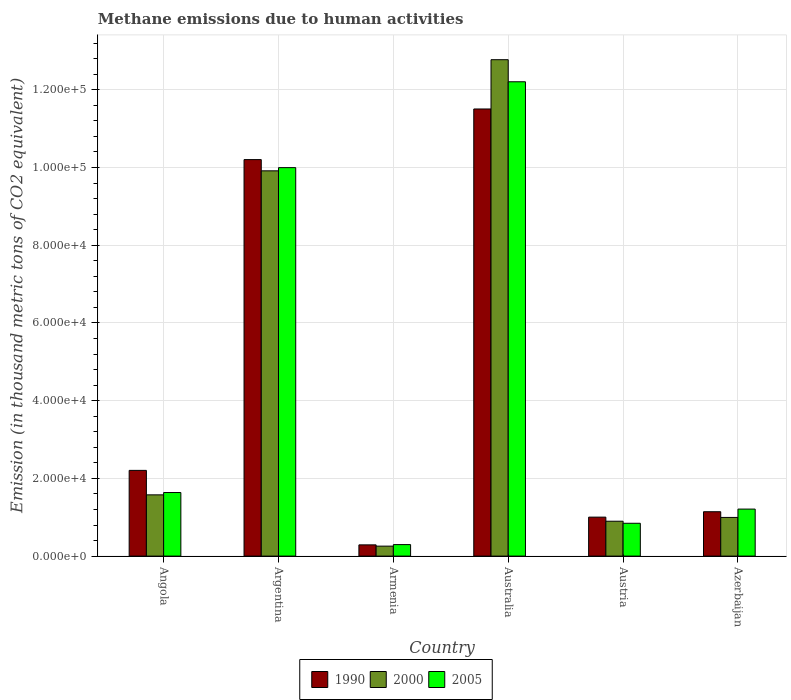How many bars are there on the 6th tick from the left?
Offer a very short reply. 3. What is the amount of methane emitted in 2005 in Austria?
Offer a very short reply. 8447.3. Across all countries, what is the maximum amount of methane emitted in 2005?
Keep it short and to the point. 1.22e+05. Across all countries, what is the minimum amount of methane emitted in 1990?
Offer a terse response. 2890.7. In which country was the amount of methane emitted in 2000 maximum?
Provide a short and direct response. Australia. In which country was the amount of methane emitted in 1990 minimum?
Ensure brevity in your answer.  Armenia. What is the total amount of methane emitted in 2000 in the graph?
Ensure brevity in your answer.  2.64e+05. What is the difference between the amount of methane emitted in 1990 in Angola and that in Azerbaijan?
Offer a very short reply. 1.06e+04. What is the difference between the amount of methane emitted in 2005 in Armenia and the amount of methane emitted in 2000 in Azerbaijan?
Provide a short and direct response. -6990.6. What is the average amount of methane emitted in 2005 per country?
Provide a succinct answer. 4.36e+04. What is the difference between the amount of methane emitted of/in 2000 and amount of methane emitted of/in 2005 in Austria?
Offer a terse response. 525.1. In how many countries, is the amount of methane emitted in 2000 greater than 24000 thousand metric tons?
Your answer should be very brief. 2. What is the ratio of the amount of methane emitted in 2000 in Angola to that in Australia?
Ensure brevity in your answer.  0.12. Is the amount of methane emitted in 1990 in Argentina less than that in Azerbaijan?
Offer a terse response. No. What is the difference between the highest and the second highest amount of methane emitted in 2005?
Make the answer very short. 8.36e+04. What is the difference between the highest and the lowest amount of methane emitted in 2005?
Your answer should be compact. 1.19e+05. Is it the case that in every country, the sum of the amount of methane emitted in 2005 and amount of methane emitted in 1990 is greater than the amount of methane emitted in 2000?
Provide a short and direct response. Yes. How many countries are there in the graph?
Give a very brief answer. 6. What is the difference between two consecutive major ticks on the Y-axis?
Ensure brevity in your answer.  2.00e+04. Are the values on the major ticks of Y-axis written in scientific E-notation?
Your response must be concise. Yes. Does the graph contain any zero values?
Your answer should be very brief. No. Does the graph contain grids?
Provide a succinct answer. Yes. How many legend labels are there?
Offer a terse response. 3. What is the title of the graph?
Offer a very short reply. Methane emissions due to human activities. What is the label or title of the X-axis?
Give a very brief answer. Country. What is the label or title of the Y-axis?
Give a very brief answer. Emission (in thousand metric tons of CO2 equivalent). What is the Emission (in thousand metric tons of CO2 equivalent) in 1990 in Angola?
Offer a terse response. 2.21e+04. What is the Emission (in thousand metric tons of CO2 equivalent) in 2000 in Angola?
Your response must be concise. 1.58e+04. What is the Emission (in thousand metric tons of CO2 equivalent) of 2005 in Angola?
Ensure brevity in your answer.  1.64e+04. What is the Emission (in thousand metric tons of CO2 equivalent) of 1990 in Argentina?
Keep it short and to the point. 1.02e+05. What is the Emission (in thousand metric tons of CO2 equivalent) of 2000 in Argentina?
Provide a succinct answer. 9.91e+04. What is the Emission (in thousand metric tons of CO2 equivalent) of 2005 in Argentina?
Your answer should be very brief. 1.00e+05. What is the Emission (in thousand metric tons of CO2 equivalent) of 1990 in Armenia?
Ensure brevity in your answer.  2890.7. What is the Emission (in thousand metric tons of CO2 equivalent) of 2000 in Armenia?
Give a very brief answer. 2565.3. What is the Emission (in thousand metric tons of CO2 equivalent) of 2005 in Armenia?
Your answer should be compact. 2960.3. What is the Emission (in thousand metric tons of CO2 equivalent) of 1990 in Australia?
Provide a short and direct response. 1.15e+05. What is the Emission (in thousand metric tons of CO2 equivalent) in 2000 in Australia?
Offer a very short reply. 1.28e+05. What is the Emission (in thousand metric tons of CO2 equivalent) of 2005 in Australia?
Offer a terse response. 1.22e+05. What is the Emission (in thousand metric tons of CO2 equivalent) of 1990 in Austria?
Offer a very short reply. 1.00e+04. What is the Emission (in thousand metric tons of CO2 equivalent) of 2000 in Austria?
Your response must be concise. 8972.4. What is the Emission (in thousand metric tons of CO2 equivalent) in 2005 in Austria?
Keep it short and to the point. 8447.3. What is the Emission (in thousand metric tons of CO2 equivalent) of 1990 in Azerbaijan?
Your response must be concise. 1.14e+04. What is the Emission (in thousand metric tons of CO2 equivalent) of 2000 in Azerbaijan?
Provide a succinct answer. 9950.9. What is the Emission (in thousand metric tons of CO2 equivalent) in 2005 in Azerbaijan?
Offer a very short reply. 1.21e+04. Across all countries, what is the maximum Emission (in thousand metric tons of CO2 equivalent) of 1990?
Ensure brevity in your answer.  1.15e+05. Across all countries, what is the maximum Emission (in thousand metric tons of CO2 equivalent) in 2000?
Make the answer very short. 1.28e+05. Across all countries, what is the maximum Emission (in thousand metric tons of CO2 equivalent) in 2005?
Ensure brevity in your answer.  1.22e+05. Across all countries, what is the minimum Emission (in thousand metric tons of CO2 equivalent) of 1990?
Give a very brief answer. 2890.7. Across all countries, what is the minimum Emission (in thousand metric tons of CO2 equivalent) of 2000?
Offer a very short reply. 2565.3. Across all countries, what is the minimum Emission (in thousand metric tons of CO2 equivalent) in 2005?
Your answer should be very brief. 2960.3. What is the total Emission (in thousand metric tons of CO2 equivalent) of 1990 in the graph?
Make the answer very short. 2.63e+05. What is the total Emission (in thousand metric tons of CO2 equivalent) in 2000 in the graph?
Make the answer very short. 2.64e+05. What is the total Emission (in thousand metric tons of CO2 equivalent) of 2005 in the graph?
Give a very brief answer. 2.62e+05. What is the difference between the Emission (in thousand metric tons of CO2 equivalent) of 1990 in Angola and that in Argentina?
Provide a short and direct response. -8.00e+04. What is the difference between the Emission (in thousand metric tons of CO2 equivalent) of 2000 in Angola and that in Argentina?
Give a very brief answer. -8.34e+04. What is the difference between the Emission (in thousand metric tons of CO2 equivalent) of 2005 in Angola and that in Argentina?
Ensure brevity in your answer.  -8.36e+04. What is the difference between the Emission (in thousand metric tons of CO2 equivalent) in 1990 in Angola and that in Armenia?
Your response must be concise. 1.92e+04. What is the difference between the Emission (in thousand metric tons of CO2 equivalent) in 2000 in Angola and that in Armenia?
Make the answer very short. 1.32e+04. What is the difference between the Emission (in thousand metric tons of CO2 equivalent) in 2005 in Angola and that in Armenia?
Ensure brevity in your answer.  1.34e+04. What is the difference between the Emission (in thousand metric tons of CO2 equivalent) in 1990 in Angola and that in Australia?
Your answer should be very brief. -9.30e+04. What is the difference between the Emission (in thousand metric tons of CO2 equivalent) of 2000 in Angola and that in Australia?
Provide a short and direct response. -1.12e+05. What is the difference between the Emission (in thousand metric tons of CO2 equivalent) of 2005 in Angola and that in Australia?
Provide a succinct answer. -1.06e+05. What is the difference between the Emission (in thousand metric tons of CO2 equivalent) of 1990 in Angola and that in Austria?
Make the answer very short. 1.20e+04. What is the difference between the Emission (in thousand metric tons of CO2 equivalent) of 2000 in Angola and that in Austria?
Give a very brief answer. 6786.2. What is the difference between the Emission (in thousand metric tons of CO2 equivalent) in 2005 in Angola and that in Austria?
Ensure brevity in your answer.  7911.4. What is the difference between the Emission (in thousand metric tons of CO2 equivalent) of 1990 in Angola and that in Azerbaijan?
Offer a very short reply. 1.06e+04. What is the difference between the Emission (in thousand metric tons of CO2 equivalent) in 2000 in Angola and that in Azerbaijan?
Ensure brevity in your answer.  5807.7. What is the difference between the Emission (in thousand metric tons of CO2 equivalent) of 2005 in Angola and that in Azerbaijan?
Offer a very short reply. 4262.4. What is the difference between the Emission (in thousand metric tons of CO2 equivalent) in 1990 in Argentina and that in Armenia?
Offer a very short reply. 9.91e+04. What is the difference between the Emission (in thousand metric tons of CO2 equivalent) of 2000 in Argentina and that in Armenia?
Your response must be concise. 9.66e+04. What is the difference between the Emission (in thousand metric tons of CO2 equivalent) in 2005 in Argentina and that in Armenia?
Provide a short and direct response. 9.70e+04. What is the difference between the Emission (in thousand metric tons of CO2 equivalent) of 1990 in Argentina and that in Australia?
Your response must be concise. -1.30e+04. What is the difference between the Emission (in thousand metric tons of CO2 equivalent) of 2000 in Argentina and that in Australia?
Your answer should be very brief. -2.86e+04. What is the difference between the Emission (in thousand metric tons of CO2 equivalent) of 2005 in Argentina and that in Australia?
Keep it short and to the point. -2.21e+04. What is the difference between the Emission (in thousand metric tons of CO2 equivalent) in 1990 in Argentina and that in Austria?
Your answer should be very brief. 9.20e+04. What is the difference between the Emission (in thousand metric tons of CO2 equivalent) in 2000 in Argentina and that in Austria?
Give a very brief answer. 9.02e+04. What is the difference between the Emission (in thousand metric tons of CO2 equivalent) in 2005 in Argentina and that in Austria?
Your response must be concise. 9.15e+04. What is the difference between the Emission (in thousand metric tons of CO2 equivalent) in 1990 in Argentina and that in Azerbaijan?
Your answer should be compact. 9.06e+04. What is the difference between the Emission (in thousand metric tons of CO2 equivalent) in 2000 in Argentina and that in Azerbaijan?
Keep it short and to the point. 8.92e+04. What is the difference between the Emission (in thousand metric tons of CO2 equivalent) in 2005 in Argentina and that in Azerbaijan?
Provide a succinct answer. 8.79e+04. What is the difference between the Emission (in thousand metric tons of CO2 equivalent) of 1990 in Armenia and that in Australia?
Your answer should be very brief. -1.12e+05. What is the difference between the Emission (in thousand metric tons of CO2 equivalent) in 2000 in Armenia and that in Australia?
Keep it short and to the point. -1.25e+05. What is the difference between the Emission (in thousand metric tons of CO2 equivalent) in 2005 in Armenia and that in Australia?
Offer a very short reply. -1.19e+05. What is the difference between the Emission (in thousand metric tons of CO2 equivalent) in 1990 in Armenia and that in Austria?
Your answer should be very brief. -7135.8. What is the difference between the Emission (in thousand metric tons of CO2 equivalent) in 2000 in Armenia and that in Austria?
Offer a very short reply. -6407.1. What is the difference between the Emission (in thousand metric tons of CO2 equivalent) of 2005 in Armenia and that in Austria?
Your answer should be very brief. -5487. What is the difference between the Emission (in thousand metric tons of CO2 equivalent) of 1990 in Armenia and that in Azerbaijan?
Your answer should be compact. -8527.5. What is the difference between the Emission (in thousand metric tons of CO2 equivalent) of 2000 in Armenia and that in Azerbaijan?
Your answer should be compact. -7385.6. What is the difference between the Emission (in thousand metric tons of CO2 equivalent) of 2005 in Armenia and that in Azerbaijan?
Provide a succinct answer. -9136. What is the difference between the Emission (in thousand metric tons of CO2 equivalent) of 1990 in Australia and that in Austria?
Provide a short and direct response. 1.05e+05. What is the difference between the Emission (in thousand metric tons of CO2 equivalent) of 2000 in Australia and that in Austria?
Ensure brevity in your answer.  1.19e+05. What is the difference between the Emission (in thousand metric tons of CO2 equivalent) of 2005 in Australia and that in Austria?
Provide a short and direct response. 1.14e+05. What is the difference between the Emission (in thousand metric tons of CO2 equivalent) in 1990 in Australia and that in Azerbaijan?
Keep it short and to the point. 1.04e+05. What is the difference between the Emission (in thousand metric tons of CO2 equivalent) of 2000 in Australia and that in Azerbaijan?
Provide a succinct answer. 1.18e+05. What is the difference between the Emission (in thousand metric tons of CO2 equivalent) of 2005 in Australia and that in Azerbaijan?
Ensure brevity in your answer.  1.10e+05. What is the difference between the Emission (in thousand metric tons of CO2 equivalent) of 1990 in Austria and that in Azerbaijan?
Your response must be concise. -1391.7. What is the difference between the Emission (in thousand metric tons of CO2 equivalent) in 2000 in Austria and that in Azerbaijan?
Your answer should be very brief. -978.5. What is the difference between the Emission (in thousand metric tons of CO2 equivalent) in 2005 in Austria and that in Azerbaijan?
Your response must be concise. -3649. What is the difference between the Emission (in thousand metric tons of CO2 equivalent) in 1990 in Angola and the Emission (in thousand metric tons of CO2 equivalent) in 2000 in Argentina?
Offer a very short reply. -7.71e+04. What is the difference between the Emission (in thousand metric tons of CO2 equivalent) of 1990 in Angola and the Emission (in thousand metric tons of CO2 equivalent) of 2005 in Argentina?
Offer a terse response. -7.79e+04. What is the difference between the Emission (in thousand metric tons of CO2 equivalent) in 2000 in Angola and the Emission (in thousand metric tons of CO2 equivalent) in 2005 in Argentina?
Offer a very short reply. -8.42e+04. What is the difference between the Emission (in thousand metric tons of CO2 equivalent) of 1990 in Angola and the Emission (in thousand metric tons of CO2 equivalent) of 2000 in Armenia?
Keep it short and to the point. 1.95e+04. What is the difference between the Emission (in thousand metric tons of CO2 equivalent) in 1990 in Angola and the Emission (in thousand metric tons of CO2 equivalent) in 2005 in Armenia?
Your answer should be compact. 1.91e+04. What is the difference between the Emission (in thousand metric tons of CO2 equivalent) of 2000 in Angola and the Emission (in thousand metric tons of CO2 equivalent) of 2005 in Armenia?
Ensure brevity in your answer.  1.28e+04. What is the difference between the Emission (in thousand metric tons of CO2 equivalent) of 1990 in Angola and the Emission (in thousand metric tons of CO2 equivalent) of 2000 in Australia?
Your response must be concise. -1.06e+05. What is the difference between the Emission (in thousand metric tons of CO2 equivalent) of 1990 in Angola and the Emission (in thousand metric tons of CO2 equivalent) of 2005 in Australia?
Your answer should be very brief. -1.00e+05. What is the difference between the Emission (in thousand metric tons of CO2 equivalent) of 2000 in Angola and the Emission (in thousand metric tons of CO2 equivalent) of 2005 in Australia?
Your answer should be compact. -1.06e+05. What is the difference between the Emission (in thousand metric tons of CO2 equivalent) in 1990 in Angola and the Emission (in thousand metric tons of CO2 equivalent) in 2000 in Austria?
Your answer should be compact. 1.31e+04. What is the difference between the Emission (in thousand metric tons of CO2 equivalent) in 1990 in Angola and the Emission (in thousand metric tons of CO2 equivalent) in 2005 in Austria?
Give a very brief answer. 1.36e+04. What is the difference between the Emission (in thousand metric tons of CO2 equivalent) of 2000 in Angola and the Emission (in thousand metric tons of CO2 equivalent) of 2005 in Austria?
Give a very brief answer. 7311.3. What is the difference between the Emission (in thousand metric tons of CO2 equivalent) in 1990 in Angola and the Emission (in thousand metric tons of CO2 equivalent) in 2000 in Azerbaijan?
Ensure brevity in your answer.  1.21e+04. What is the difference between the Emission (in thousand metric tons of CO2 equivalent) in 1990 in Angola and the Emission (in thousand metric tons of CO2 equivalent) in 2005 in Azerbaijan?
Ensure brevity in your answer.  9960.3. What is the difference between the Emission (in thousand metric tons of CO2 equivalent) of 2000 in Angola and the Emission (in thousand metric tons of CO2 equivalent) of 2005 in Azerbaijan?
Provide a short and direct response. 3662.3. What is the difference between the Emission (in thousand metric tons of CO2 equivalent) of 1990 in Argentina and the Emission (in thousand metric tons of CO2 equivalent) of 2000 in Armenia?
Provide a succinct answer. 9.95e+04. What is the difference between the Emission (in thousand metric tons of CO2 equivalent) of 1990 in Argentina and the Emission (in thousand metric tons of CO2 equivalent) of 2005 in Armenia?
Give a very brief answer. 9.91e+04. What is the difference between the Emission (in thousand metric tons of CO2 equivalent) in 2000 in Argentina and the Emission (in thousand metric tons of CO2 equivalent) in 2005 in Armenia?
Offer a terse response. 9.62e+04. What is the difference between the Emission (in thousand metric tons of CO2 equivalent) of 1990 in Argentina and the Emission (in thousand metric tons of CO2 equivalent) of 2000 in Australia?
Provide a short and direct response. -2.57e+04. What is the difference between the Emission (in thousand metric tons of CO2 equivalent) of 1990 in Argentina and the Emission (in thousand metric tons of CO2 equivalent) of 2005 in Australia?
Keep it short and to the point. -2.00e+04. What is the difference between the Emission (in thousand metric tons of CO2 equivalent) of 2000 in Argentina and the Emission (in thousand metric tons of CO2 equivalent) of 2005 in Australia?
Make the answer very short. -2.29e+04. What is the difference between the Emission (in thousand metric tons of CO2 equivalent) in 1990 in Argentina and the Emission (in thousand metric tons of CO2 equivalent) in 2000 in Austria?
Make the answer very short. 9.31e+04. What is the difference between the Emission (in thousand metric tons of CO2 equivalent) in 1990 in Argentina and the Emission (in thousand metric tons of CO2 equivalent) in 2005 in Austria?
Your answer should be very brief. 9.36e+04. What is the difference between the Emission (in thousand metric tons of CO2 equivalent) in 2000 in Argentina and the Emission (in thousand metric tons of CO2 equivalent) in 2005 in Austria?
Your response must be concise. 9.07e+04. What is the difference between the Emission (in thousand metric tons of CO2 equivalent) of 1990 in Argentina and the Emission (in thousand metric tons of CO2 equivalent) of 2000 in Azerbaijan?
Provide a succinct answer. 9.21e+04. What is the difference between the Emission (in thousand metric tons of CO2 equivalent) in 1990 in Argentina and the Emission (in thousand metric tons of CO2 equivalent) in 2005 in Azerbaijan?
Your answer should be very brief. 8.99e+04. What is the difference between the Emission (in thousand metric tons of CO2 equivalent) of 2000 in Argentina and the Emission (in thousand metric tons of CO2 equivalent) of 2005 in Azerbaijan?
Ensure brevity in your answer.  8.70e+04. What is the difference between the Emission (in thousand metric tons of CO2 equivalent) in 1990 in Armenia and the Emission (in thousand metric tons of CO2 equivalent) in 2000 in Australia?
Keep it short and to the point. -1.25e+05. What is the difference between the Emission (in thousand metric tons of CO2 equivalent) in 1990 in Armenia and the Emission (in thousand metric tons of CO2 equivalent) in 2005 in Australia?
Make the answer very short. -1.19e+05. What is the difference between the Emission (in thousand metric tons of CO2 equivalent) of 2000 in Armenia and the Emission (in thousand metric tons of CO2 equivalent) of 2005 in Australia?
Provide a short and direct response. -1.19e+05. What is the difference between the Emission (in thousand metric tons of CO2 equivalent) of 1990 in Armenia and the Emission (in thousand metric tons of CO2 equivalent) of 2000 in Austria?
Provide a short and direct response. -6081.7. What is the difference between the Emission (in thousand metric tons of CO2 equivalent) of 1990 in Armenia and the Emission (in thousand metric tons of CO2 equivalent) of 2005 in Austria?
Provide a short and direct response. -5556.6. What is the difference between the Emission (in thousand metric tons of CO2 equivalent) of 2000 in Armenia and the Emission (in thousand metric tons of CO2 equivalent) of 2005 in Austria?
Provide a short and direct response. -5882. What is the difference between the Emission (in thousand metric tons of CO2 equivalent) in 1990 in Armenia and the Emission (in thousand metric tons of CO2 equivalent) in 2000 in Azerbaijan?
Ensure brevity in your answer.  -7060.2. What is the difference between the Emission (in thousand metric tons of CO2 equivalent) of 1990 in Armenia and the Emission (in thousand metric tons of CO2 equivalent) of 2005 in Azerbaijan?
Offer a very short reply. -9205.6. What is the difference between the Emission (in thousand metric tons of CO2 equivalent) of 2000 in Armenia and the Emission (in thousand metric tons of CO2 equivalent) of 2005 in Azerbaijan?
Offer a terse response. -9531. What is the difference between the Emission (in thousand metric tons of CO2 equivalent) in 1990 in Australia and the Emission (in thousand metric tons of CO2 equivalent) in 2000 in Austria?
Give a very brief answer. 1.06e+05. What is the difference between the Emission (in thousand metric tons of CO2 equivalent) in 1990 in Australia and the Emission (in thousand metric tons of CO2 equivalent) in 2005 in Austria?
Provide a short and direct response. 1.07e+05. What is the difference between the Emission (in thousand metric tons of CO2 equivalent) in 2000 in Australia and the Emission (in thousand metric tons of CO2 equivalent) in 2005 in Austria?
Make the answer very short. 1.19e+05. What is the difference between the Emission (in thousand metric tons of CO2 equivalent) of 1990 in Australia and the Emission (in thousand metric tons of CO2 equivalent) of 2000 in Azerbaijan?
Provide a succinct answer. 1.05e+05. What is the difference between the Emission (in thousand metric tons of CO2 equivalent) in 1990 in Australia and the Emission (in thousand metric tons of CO2 equivalent) in 2005 in Azerbaijan?
Your answer should be very brief. 1.03e+05. What is the difference between the Emission (in thousand metric tons of CO2 equivalent) in 2000 in Australia and the Emission (in thousand metric tons of CO2 equivalent) in 2005 in Azerbaijan?
Make the answer very short. 1.16e+05. What is the difference between the Emission (in thousand metric tons of CO2 equivalent) of 1990 in Austria and the Emission (in thousand metric tons of CO2 equivalent) of 2000 in Azerbaijan?
Your response must be concise. 75.6. What is the difference between the Emission (in thousand metric tons of CO2 equivalent) of 1990 in Austria and the Emission (in thousand metric tons of CO2 equivalent) of 2005 in Azerbaijan?
Provide a short and direct response. -2069.8. What is the difference between the Emission (in thousand metric tons of CO2 equivalent) of 2000 in Austria and the Emission (in thousand metric tons of CO2 equivalent) of 2005 in Azerbaijan?
Provide a succinct answer. -3123.9. What is the average Emission (in thousand metric tons of CO2 equivalent) of 1990 per country?
Provide a succinct answer. 4.39e+04. What is the average Emission (in thousand metric tons of CO2 equivalent) in 2000 per country?
Keep it short and to the point. 4.40e+04. What is the average Emission (in thousand metric tons of CO2 equivalent) in 2005 per country?
Keep it short and to the point. 4.36e+04. What is the difference between the Emission (in thousand metric tons of CO2 equivalent) in 1990 and Emission (in thousand metric tons of CO2 equivalent) in 2000 in Angola?
Provide a succinct answer. 6298. What is the difference between the Emission (in thousand metric tons of CO2 equivalent) in 1990 and Emission (in thousand metric tons of CO2 equivalent) in 2005 in Angola?
Your answer should be compact. 5697.9. What is the difference between the Emission (in thousand metric tons of CO2 equivalent) of 2000 and Emission (in thousand metric tons of CO2 equivalent) of 2005 in Angola?
Provide a succinct answer. -600.1. What is the difference between the Emission (in thousand metric tons of CO2 equivalent) of 1990 and Emission (in thousand metric tons of CO2 equivalent) of 2000 in Argentina?
Offer a terse response. 2891.1. What is the difference between the Emission (in thousand metric tons of CO2 equivalent) in 1990 and Emission (in thousand metric tons of CO2 equivalent) in 2005 in Argentina?
Keep it short and to the point. 2067.7. What is the difference between the Emission (in thousand metric tons of CO2 equivalent) of 2000 and Emission (in thousand metric tons of CO2 equivalent) of 2005 in Argentina?
Make the answer very short. -823.4. What is the difference between the Emission (in thousand metric tons of CO2 equivalent) of 1990 and Emission (in thousand metric tons of CO2 equivalent) of 2000 in Armenia?
Offer a terse response. 325.4. What is the difference between the Emission (in thousand metric tons of CO2 equivalent) in 1990 and Emission (in thousand metric tons of CO2 equivalent) in 2005 in Armenia?
Keep it short and to the point. -69.6. What is the difference between the Emission (in thousand metric tons of CO2 equivalent) in 2000 and Emission (in thousand metric tons of CO2 equivalent) in 2005 in Armenia?
Provide a short and direct response. -395. What is the difference between the Emission (in thousand metric tons of CO2 equivalent) in 1990 and Emission (in thousand metric tons of CO2 equivalent) in 2000 in Australia?
Offer a very short reply. -1.27e+04. What is the difference between the Emission (in thousand metric tons of CO2 equivalent) of 1990 and Emission (in thousand metric tons of CO2 equivalent) of 2005 in Australia?
Your answer should be very brief. -7000. What is the difference between the Emission (in thousand metric tons of CO2 equivalent) in 2000 and Emission (in thousand metric tons of CO2 equivalent) in 2005 in Australia?
Your answer should be compact. 5682.2. What is the difference between the Emission (in thousand metric tons of CO2 equivalent) in 1990 and Emission (in thousand metric tons of CO2 equivalent) in 2000 in Austria?
Make the answer very short. 1054.1. What is the difference between the Emission (in thousand metric tons of CO2 equivalent) of 1990 and Emission (in thousand metric tons of CO2 equivalent) of 2005 in Austria?
Ensure brevity in your answer.  1579.2. What is the difference between the Emission (in thousand metric tons of CO2 equivalent) in 2000 and Emission (in thousand metric tons of CO2 equivalent) in 2005 in Austria?
Keep it short and to the point. 525.1. What is the difference between the Emission (in thousand metric tons of CO2 equivalent) in 1990 and Emission (in thousand metric tons of CO2 equivalent) in 2000 in Azerbaijan?
Ensure brevity in your answer.  1467.3. What is the difference between the Emission (in thousand metric tons of CO2 equivalent) of 1990 and Emission (in thousand metric tons of CO2 equivalent) of 2005 in Azerbaijan?
Provide a succinct answer. -678.1. What is the difference between the Emission (in thousand metric tons of CO2 equivalent) in 2000 and Emission (in thousand metric tons of CO2 equivalent) in 2005 in Azerbaijan?
Make the answer very short. -2145.4. What is the ratio of the Emission (in thousand metric tons of CO2 equivalent) in 1990 in Angola to that in Argentina?
Provide a succinct answer. 0.22. What is the ratio of the Emission (in thousand metric tons of CO2 equivalent) of 2000 in Angola to that in Argentina?
Ensure brevity in your answer.  0.16. What is the ratio of the Emission (in thousand metric tons of CO2 equivalent) of 2005 in Angola to that in Argentina?
Make the answer very short. 0.16. What is the ratio of the Emission (in thousand metric tons of CO2 equivalent) in 1990 in Angola to that in Armenia?
Keep it short and to the point. 7.63. What is the ratio of the Emission (in thousand metric tons of CO2 equivalent) of 2000 in Angola to that in Armenia?
Your response must be concise. 6.14. What is the ratio of the Emission (in thousand metric tons of CO2 equivalent) in 2005 in Angola to that in Armenia?
Your answer should be very brief. 5.53. What is the ratio of the Emission (in thousand metric tons of CO2 equivalent) of 1990 in Angola to that in Australia?
Your answer should be compact. 0.19. What is the ratio of the Emission (in thousand metric tons of CO2 equivalent) of 2000 in Angola to that in Australia?
Make the answer very short. 0.12. What is the ratio of the Emission (in thousand metric tons of CO2 equivalent) in 2005 in Angola to that in Australia?
Make the answer very short. 0.13. What is the ratio of the Emission (in thousand metric tons of CO2 equivalent) in 1990 in Angola to that in Austria?
Your answer should be compact. 2.2. What is the ratio of the Emission (in thousand metric tons of CO2 equivalent) in 2000 in Angola to that in Austria?
Provide a short and direct response. 1.76. What is the ratio of the Emission (in thousand metric tons of CO2 equivalent) in 2005 in Angola to that in Austria?
Your answer should be compact. 1.94. What is the ratio of the Emission (in thousand metric tons of CO2 equivalent) of 1990 in Angola to that in Azerbaijan?
Give a very brief answer. 1.93. What is the ratio of the Emission (in thousand metric tons of CO2 equivalent) of 2000 in Angola to that in Azerbaijan?
Offer a very short reply. 1.58. What is the ratio of the Emission (in thousand metric tons of CO2 equivalent) in 2005 in Angola to that in Azerbaijan?
Offer a terse response. 1.35. What is the ratio of the Emission (in thousand metric tons of CO2 equivalent) in 1990 in Argentina to that in Armenia?
Your response must be concise. 35.29. What is the ratio of the Emission (in thousand metric tons of CO2 equivalent) of 2000 in Argentina to that in Armenia?
Your response must be concise. 38.64. What is the ratio of the Emission (in thousand metric tons of CO2 equivalent) in 2005 in Argentina to that in Armenia?
Offer a terse response. 33.77. What is the ratio of the Emission (in thousand metric tons of CO2 equivalent) of 1990 in Argentina to that in Australia?
Your answer should be very brief. 0.89. What is the ratio of the Emission (in thousand metric tons of CO2 equivalent) in 2000 in Argentina to that in Australia?
Offer a terse response. 0.78. What is the ratio of the Emission (in thousand metric tons of CO2 equivalent) of 2005 in Argentina to that in Australia?
Your answer should be very brief. 0.82. What is the ratio of the Emission (in thousand metric tons of CO2 equivalent) of 1990 in Argentina to that in Austria?
Your answer should be very brief. 10.18. What is the ratio of the Emission (in thousand metric tons of CO2 equivalent) in 2000 in Argentina to that in Austria?
Ensure brevity in your answer.  11.05. What is the ratio of the Emission (in thousand metric tons of CO2 equivalent) in 2005 in Argentina to that in Austria?
Provide a succinct answer. 11.83. What is the ratio of the Emission (in thousand metric tons of CO2 equivalent) of 1990 in Argentina to that in Azerbaijan?
Your answer should be compact. 8.94. What is the ratio of the Emission (in thousand metric tons of CO2 equivalent) in 2000 in Argentina to that in Azerbaijan?
Make the answer very short. 9.96. What is the ratio of the Emission (in thousand metric tons of CO2 equivalent) in 2005 in Argentina to that in Azerbaijan?
Provide a short and direct response. 8.26. What is the ratio of the Emission (in thousand metric tons of CO2 equivalent) in 1990 in Armenia to that in Australia?
Keep it short and to the point. 0.03. What is the ratio of the Emission (in thousand metric tons of CO2 equivalent) in 2000 in Armenia to that in Australia?
Make the answer very short. 0.02. What is the ratio of the Emission (in thousand metric tons of CO2 equivalent) of 2005 in Armenia to that in Australia?
Offer a very short reply. 0.02. What is the ratio of the Emission (in thousand metric tons of CO2 equivalent) in 1990 in Armenia to that in Austria?
Offer a terse response. 0.29. What is the ratio of the Emission (in thousand metric tons of CO2 equivalent) of 2000 in Armenia to that in Austria?
Your answer should be compact. 0.29. What is the ratio of the Emission (in thousand metric tons of CO2 equivalent) of 2005 in Armenia to that in Austria?
Give a very brief answer. 0.35. What is the ratio of the Emission (in thousand metric tons of CO2 equivalent) in 1990 in Armenia to that in Azerbaijan?
Offer a very short reply. 0.25. What is the ratio of the Emission (in thousand metric tons of CO2 equivalent) in 2000 in Armenia to that in Azerbaijan?
Keep it short and to the point. 0.26. What is the ratio of the Emission (in thousand metric tons of CO2 equivalent) of 2005 in Armenia to that in Azerbaijan?
Keep it short and to the point. 0.24. What is the ratio of the Emission (in thousand metric tons of CO2 equivalent) of 1990 in Australia to that in Austria?
Your response must be concise. 11.47. What is the ratio of the Emission (in thousand metric tons of CO2 equivalent) of 2000 in Australia to that in Austria?
Ensure brevity in your answer.  14.24. What is the ratio of the Emission (in thousand metric tons of CO2 equivalent) in 2005 in Australia to that in Austria?
Ensure brevity in your answer.  14.45. What is the ratio of the Emission (in thousand metric tons of CO2 equivalent) of 1990 in Australia to that in Azerbaijan?
Offer a terse response. 10.08. What is the ratio of the Emission (in thousand metric tons of CO2 equivalent) in 2000 in Australia to that in Azerbaijan?
Give a very brief answer. 12.84. What is the ratio of the Emission (in thousand metric tons of CO2 equivalent) of 2005 in Australia to that in Azerbaijan?
Offer a terse response. 10.09. What is the ratio of the Emission (in thousand metric tons of CO2 equivalent) in 1990 in Austria to that in Azerbaijan?
Give a very brief answer. 0.88. What is the ratio of the Emission (in thousand metric tons of CO2 equivalent) of 2000 in Austria to that in Azerbaijan?
Your response must be concise. 0.9. What is the ratio of the Emission (in thousand metric tons of CO2 equivalent) in 2005 in Austria to that in Azerbaijan?
Offer a very short reply. 0.7. What is the difference between the highest and the second highest Emission (in thousand metric tons of CO2 equivalent) in 1990?
Offer a terse response. 1.30e+04. What is the difference between the highest and the second highest Emission (in thousand metric tons of CO2 equivalent) of 2000?
Give a very brief answer. 2.86e+04. What is the difference between the highest and the second highest Emission (in thousand metric tons of CO2 equivalent) in 2005?
Your answer should be compact. 2.21e+04. What is the difference between the highest and the lowest Emission (in thousand metric tons of CO2 equivalent) in 1990?
Keep it short and to the point. 1.12e+05. What is the difference between the highest and the lowest Emission (in thousand metric tons of CO2 equivalent) of 2000?
Offer a terse response. 1.25e+05. What is the difference between the highest and the lowest Emission (in thousand metric tons of CO2 equivalent) of 2005?
Keep it short and to the point. 1.19e+05. 